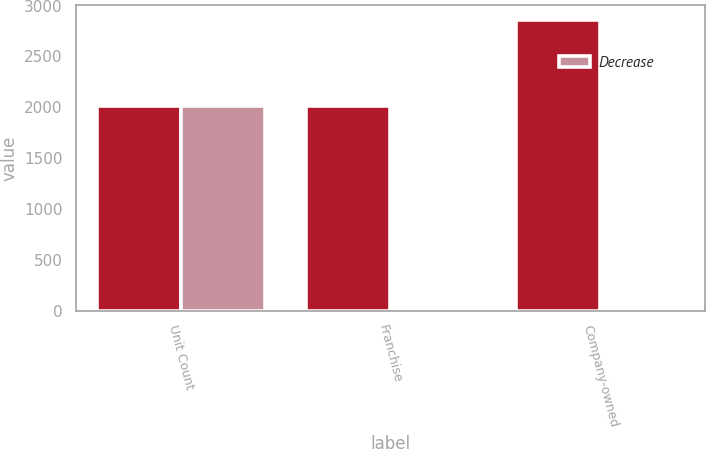Convert chart to OTSL. <chart><loc_0><loc_0><loc_500><loc_500><stacked_bar_chart><ecel><fcel>Unit Count<fcel>Franchise<fcel>Company-owned<nl><fcel>nan<fcel>2016<fcel>2016<fcel>2859<nl><fcel>Decrease<fcel>2016<fcel>4<fcel>9<nl></chart> 